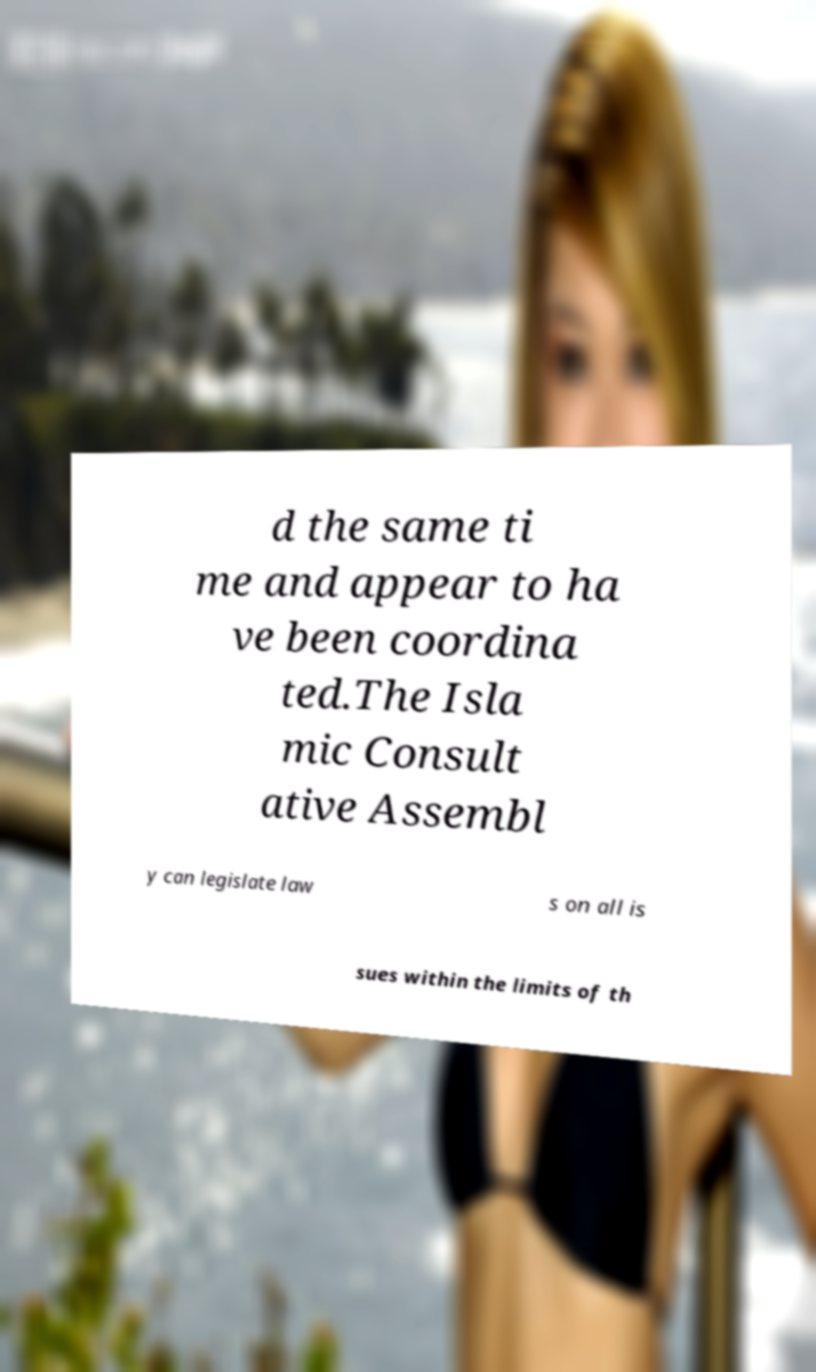Could you extract and type out the text from this image? d the same ti me and appear to ha ve been coordina ted.The Isla mic Consult ative Assembl y can legislate law s on all is sues within the limits of th 